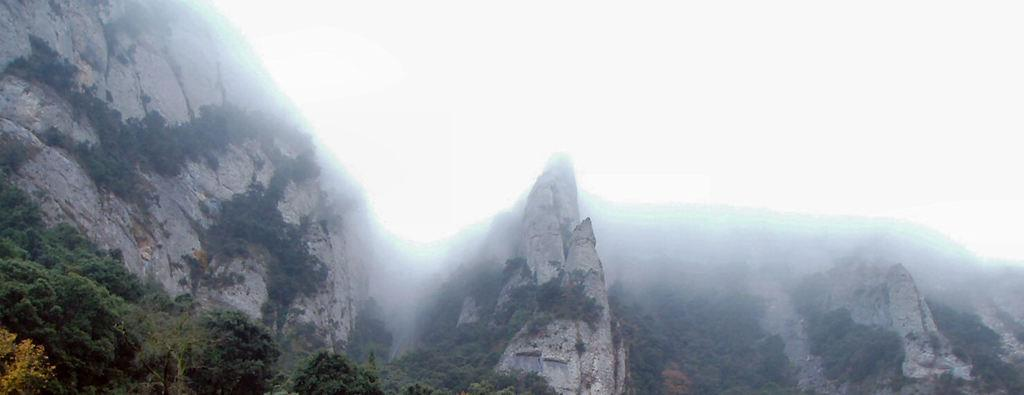What type of natural landform is present in the image? The image contains mountains. What type of vegetation can be seen at the base of the mountains? There are trees at the bottom of the image. What part of the natural environment is visible in the image? The sky is visible at the top of the image. Can you tell me how many points are visible on the mountains in the image? There is no mention of points on the mountains in the image, so it cannot be determined from the image. 